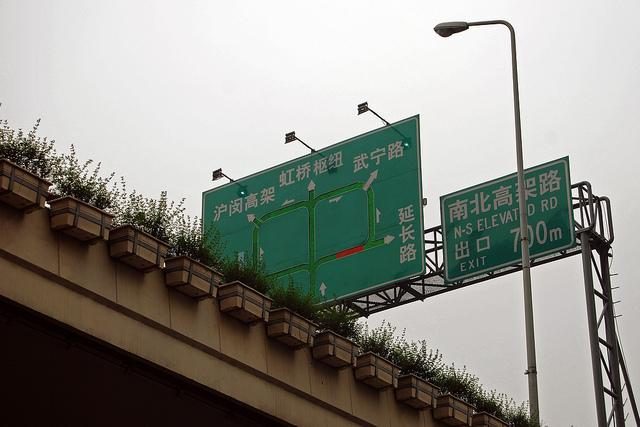According to the evidence up above where might you find the cameraman? below 